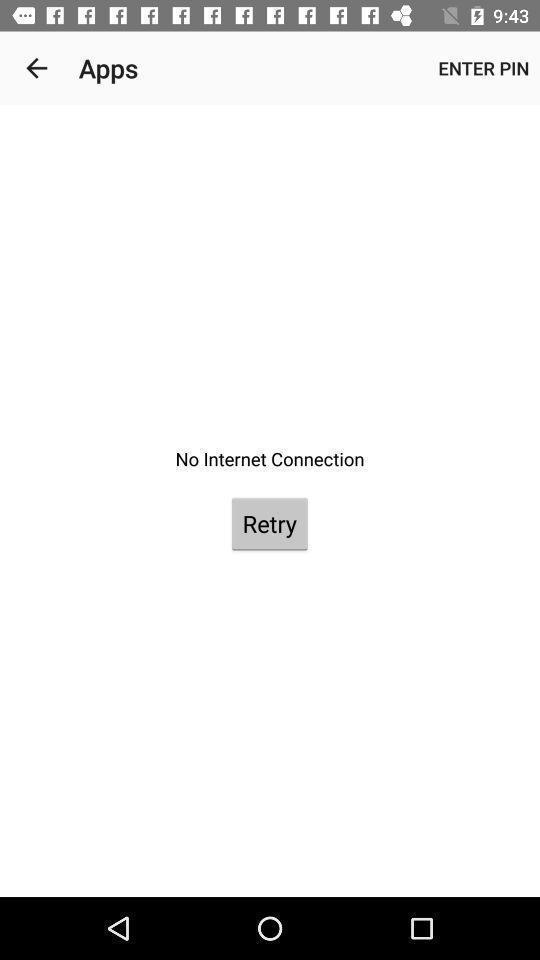Give me a narrative description of this picture. Screen shows about to internet connection. 